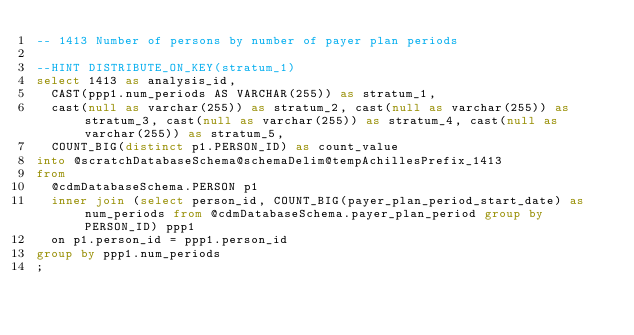<code> <loc_0><loc_0><loc_500><loc_500><_SQL_>-- 1413	Number of persons by number of payer plan periods

--HINT DISTRIBUTE_ON_KEY(stratum_1)
select 1413 as analysis_id,  
	CAST(ppp1.num_periods AS VARCHAR(255)) as stratum_1,
	cast(null as varchar(255)) as stratum_2, cast(null as varchar(255)) as stratum_3, cast(null as varchar(255)) as stratum_4, cast(null as varchar(255)) as stratum_5,
	COUNT_BIG(distinct p1.PERSON_ID) as count_value
into @scratchDatabaseSchema@schemaDelim@tempAchillesPrefix_1413
from
	@cdmDatabaseSchema.PERSON p1
	inner join (select person_id, COUNT_BIG(payer_plan_period_start_date) as num_periods from @cdmDatabaseSchema.payer_plan_period group by PERSON_ID) ppp1
	on p1.person_id = ppp1.person_id
group by ppp1.num_periods
;
</code> 